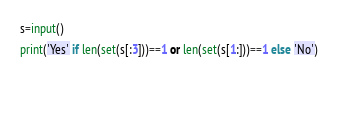Convert code to text. <code><loc_0><loc_0><loc_500><loc_500><_Python_>s=input()
print('Yes' if len(set(s[:3]))==1 or len(set(s[1:]))==1 else 'No')
  
 </code> 